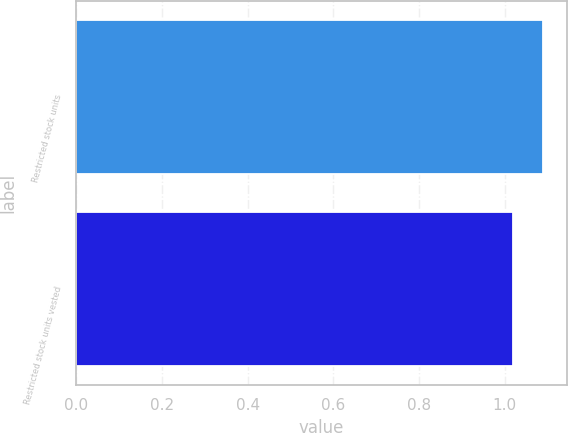<chart> <loc_0><loc_0><loc_500><loc_500><bar_chart><fcel>Restricted stock units<fcel>Restricted stock units vested<nl><fcel>1.09<fcel>1.02<nl></chart> 